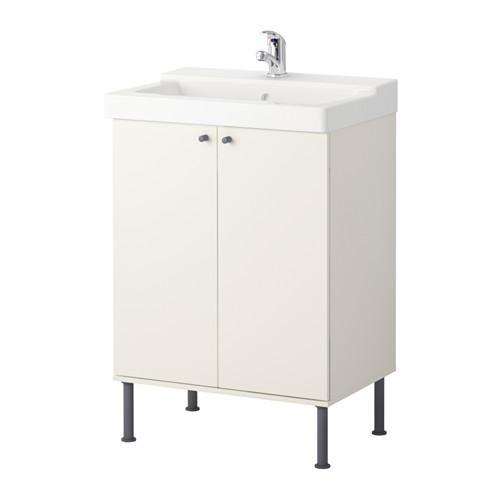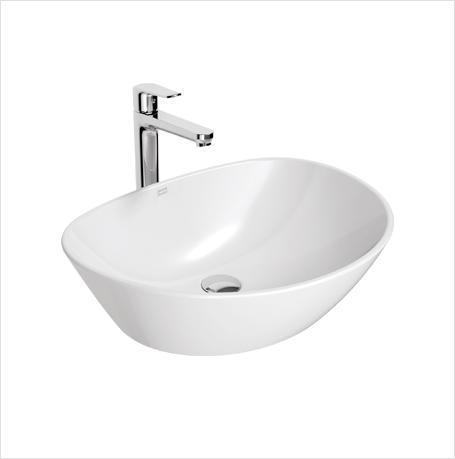The first image is the image on the left, the second image is the image on the right. Considering the images on both sides, is "The drain in the bottom of the basin is visible in the image on the right." valid? Answer yes or no. Yes. 